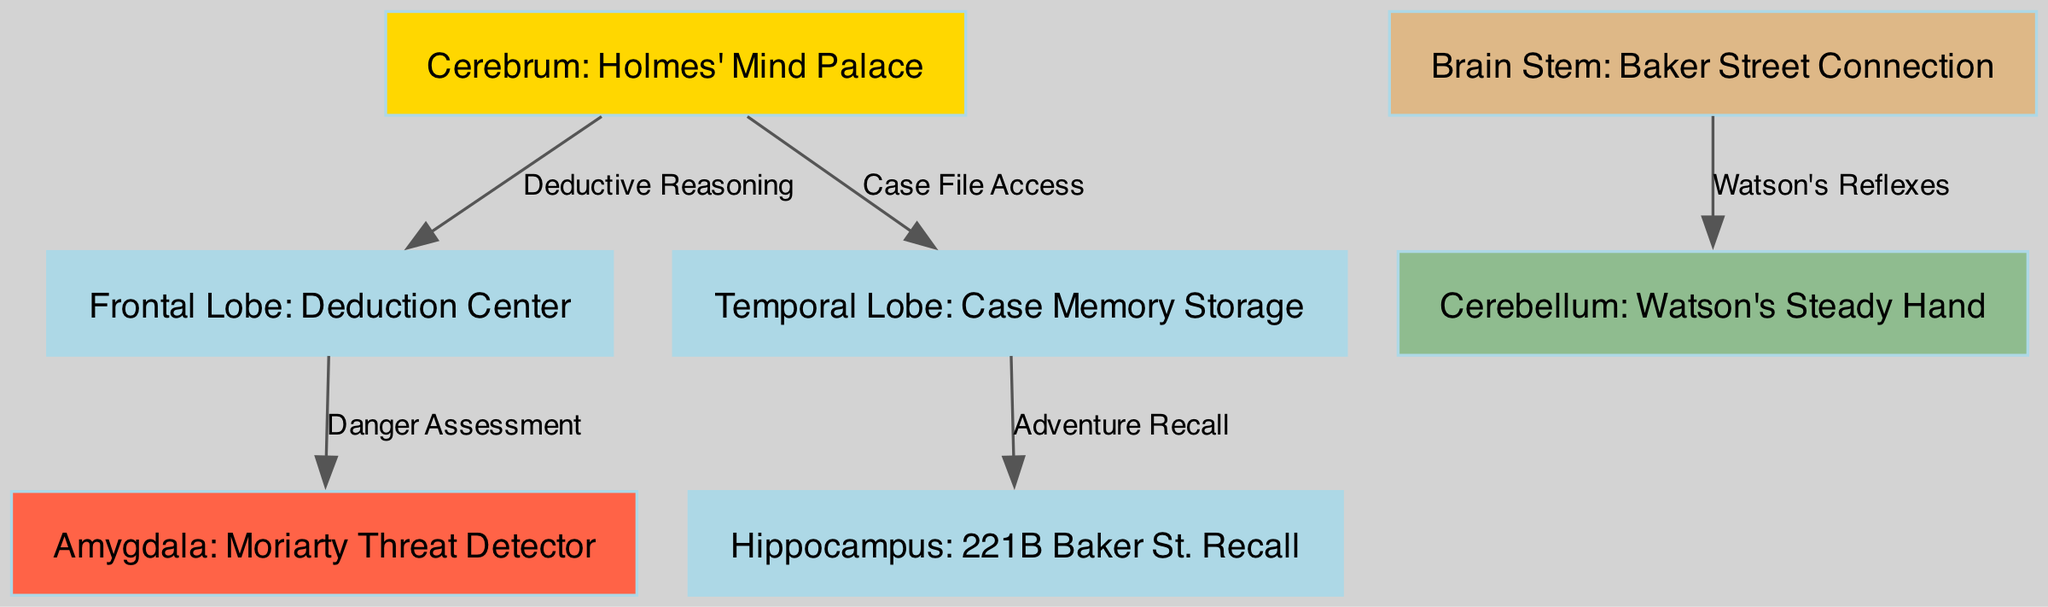What is the label of the node representing the danger assessment? The node connecting to the amygdala is labeled "Danger Assessment," indicating it is focused on evaluating threats, which is a function of the amygdala as represented in the diagram.
Answer: Danger Assessment How many parts are labeled in the diagram? By counting the nodes listed in the data, there are a total of seven parts labeled, indicating the various regions and structures of the brain pertinent to the diagram.
Answer: 7 Which part of the brain is associated with case file access? The temporal lobe is directly connected to the cerebrum with a label "Case File Access," indicating it is involved in retrieving information related to cases.
Answer: Temporal Lobe What connects the brain stem to the cerebellum? The edge from the brain stem to the cerebellum indicates "Watson's Reflexes," which highlights the relationship between these two regions in terms of reflexive actions.
Answer: Watson's Reflexes Which two parts of the brain are interconnected for adventure recall? The edge labeled with "Adventure Recall" shows the connection between the temporal lobe and the hippocampus, demonstrating their collaborative role in recalling past experiences.
Answer: Temporal Lobe and Hippocampus What color represents Holmes' Mind Palace? In the diagram, Holmes' Mind Palace is represented in golden color for the cerebrum node, emphasizing its importance as the center of reasoning and thought processes.
Answer: Golden How does the frontal lobe relate to the amygdala? The edge from the frontal lobe to the amygdala is labeled "Danger Assessment," signifying that the frontal lobe assesses situations and sends information regarding danger to the amygdala for further emotional processing.
Answer: Danger Assessment Which part of the brain is labeled as Watson's steady hand? The cerebellum is designated as "Watson's Steady Hand," illustrating its function in maintaining balance and coordinating voluntary movements, just like Dr. Watson in his actions.
Answer: Cerebellum What is the primary function associated with the hippocampus in this diagram? The label "221B Baker St. Recall" indicates the primary function of the hippocampus is to help recall specific memories, connecting it to the famous address linked to Holmes and Watson.
Answer: 221B Baker St. Recall 